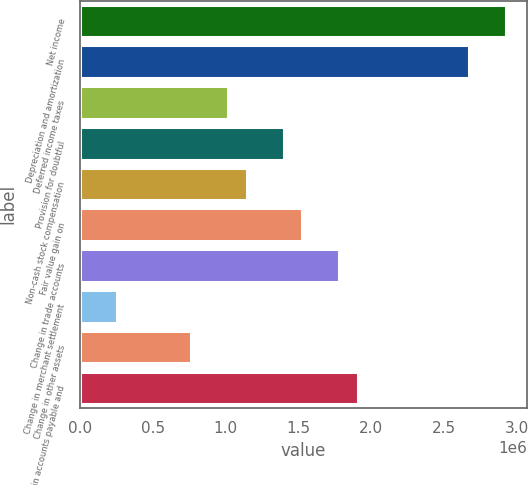Convert chart to OTSL. <chart><loc_0><loc_0><loc_500><loc_500><bar_chart><fcel>Net income<fcel>Depreciation and amortization<fcel>Deferred income taxes<fcel>Provision for doubtful<fcel>Non-cash stock compensation<fcel>Fair value gain on<fcel>Change in trade accounts<fcel>Change in merchant settlement<fcel>Change in other assets<fcel>Change in accounts payable and<nl><fcel>2.92523e+06<fcel>2.67093e+06<fcel>1.01796e+06<fcel>1.39941e+06<fcel>1.14511e+06<fcel>1.52656e+06<fcel>1.78087e+06<fcel>255046<fcel>763653<fcel>1.90802e+06<nl></chart> 